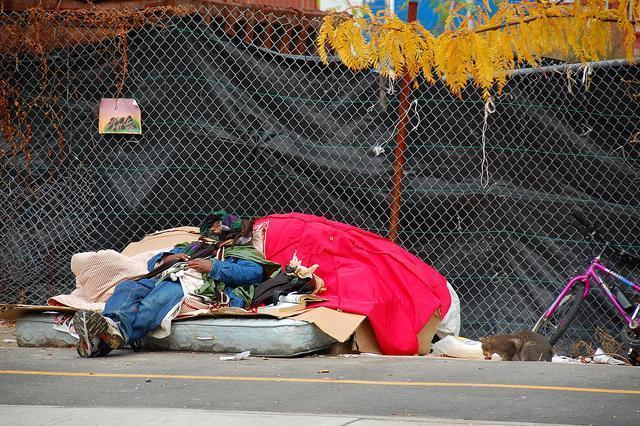How many bicycles are in the picture?
Give a very brief answer. 1. 